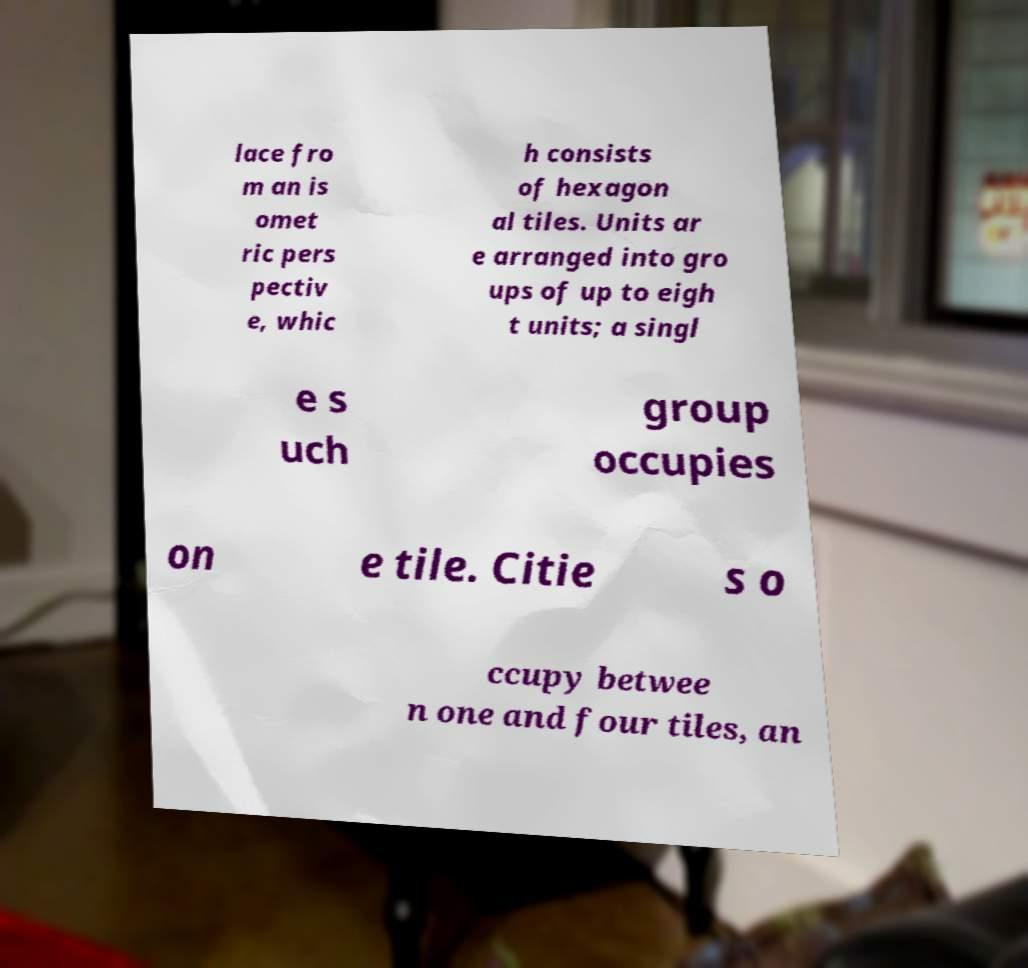Can you accurately transcribe the text from the provided image for me? lace fro m an is omet ric pers pectiv e, whic h consists of hexagon al tiles. Units ar e arranged into gro ups of up to eigh t units; a singl e s uch group occupies on e tile. Citie s o ccupy betwee n one and four tiles, an 